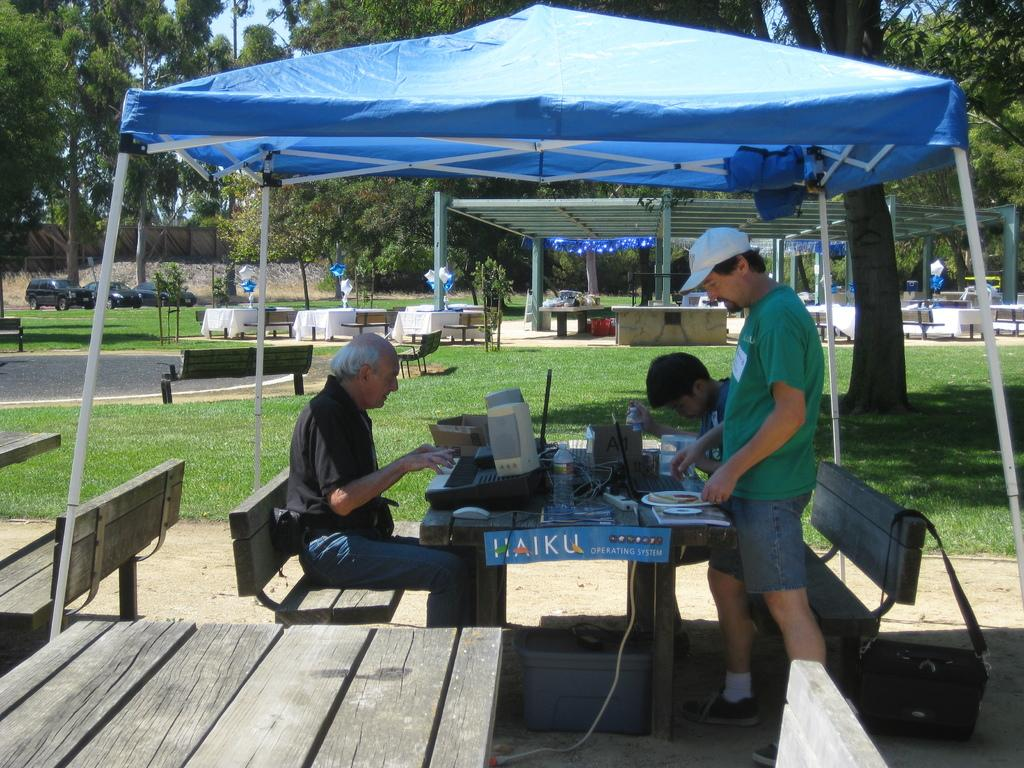What is the man in the image doing? The man is standing in the image. What are the people near the table doing? There is a group of people sitting in chairs near a table. What can be seen in the background of the image? There is a car, a tree, a tent, and benches in the background of the image. What type of light is being used to illuminate the argument in the image? There is no argument present in the image, and therefore no specific type of light is being used to illuminate it. 